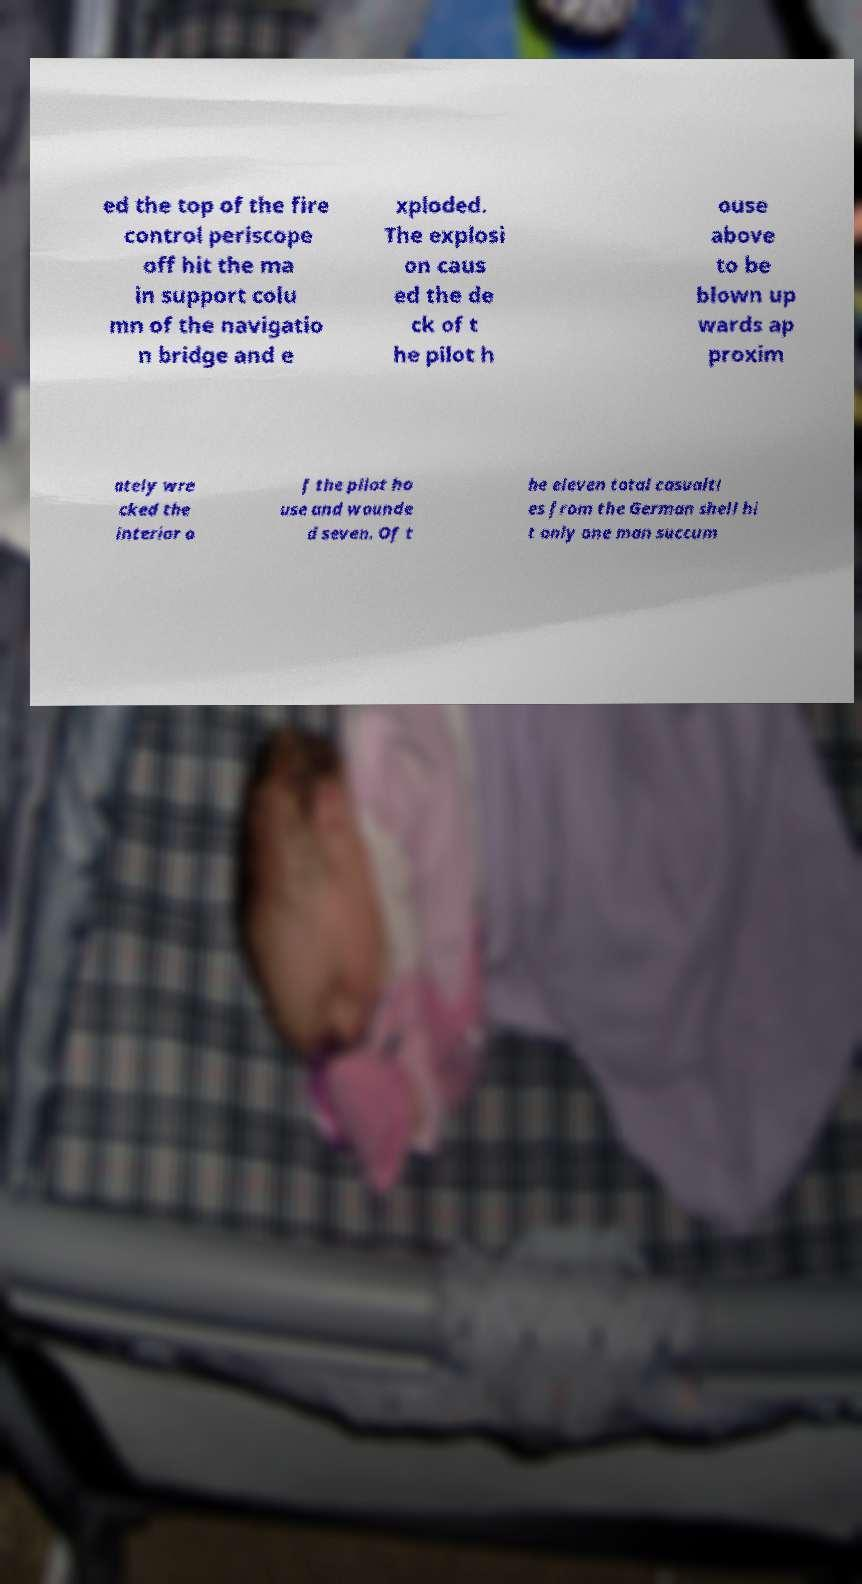Can you accurately transcribe the text from the provided image for me? ed the top of the fire control periscope off hit the ma in support colu mn of the navigatio n bridge and e xploded. The explosi on caus ed the de ck of t he pilot h ouse above to be blown up wards ap proxim ately wre cked the interior o f the pilot ho use and wounde d seven. Of t he eleven total casualti es from the German shell hi t only one man succum 